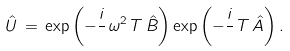<formula> <loc_0><loc_0><loc_500><loc_500>\hat { U } \, = \, \exp \left ( - \frac { i } { } \, \omega ^ { 2 } \, T \, \hat { B } \right ) \exp \left ( - \frac { i } { } \, T \, \hat { A } \right ) .</formula> 